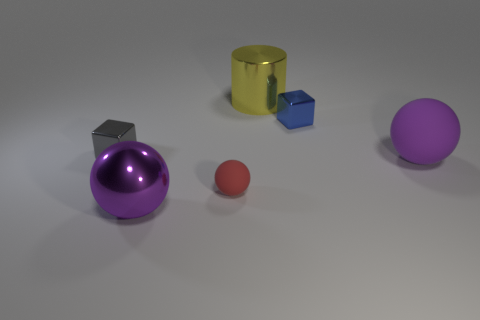Do the red matte sphere and the purple shiny ball have the same size?
Your response must be concise. No. Are there more cylinders to the right of the yellow metallic thing than large cylinders that are in front of the tiny blue object?
Ensure brevity in your answer.  No. How many other things are there of the same size as the gray metallic cube?
Your answer should be very brief. 2. Is the color of the matte object to the left of the large cylinder the same as the metallic cylinder?
Offer a very short reply. No. Are there more tiny red things that are left of the shiny sphere than red spheres?
Your response must be concise. No. Are there any other things of the same color as the cylinder?
Make the answer very short. No. There is a large thing that is behind the tiny thing on the left side of the red sphere; what shape is it?
Provide a short and direct response. Cylinder. Is the number of red balls greater than the number of small green metal things?
Your response must be concise. Yes. What number of metal objects are both behind the small rubber sphere and in front of the big metallic cylinder?
Keep it short and to the point. 2. How many large purple rubber spheres are behind the shiny block to the right of the small red ball?
Make the answer very short. 0. 